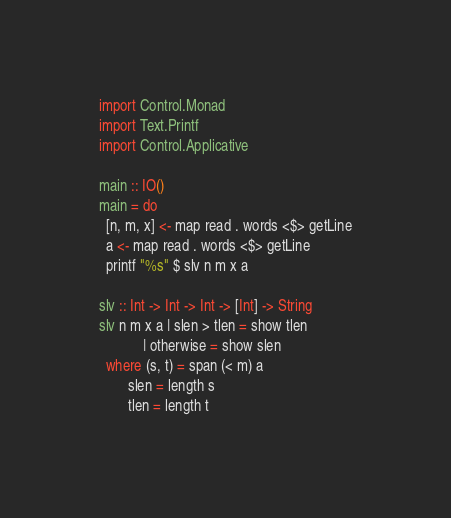Convert code to text. <code><loc_0><loc_0><loc_500><loc_500><_Haskell_>import Control.Monad
import Text.Printf
import Control.Applicative

main :: IO()
main = do
  [n, m, x] <- map read . words <$> getLine
  a <- map read . words <$> getLine
  printf "%s" $ slv n m x a

slv :: Int -> Int -> Int -> [Int] -> String
slv n m x a | slen > tlen = show tlen
            | otherwise = show slen
  where (s, t) = span (< m) a
        slen = length s
        tlen = length t
</code> 